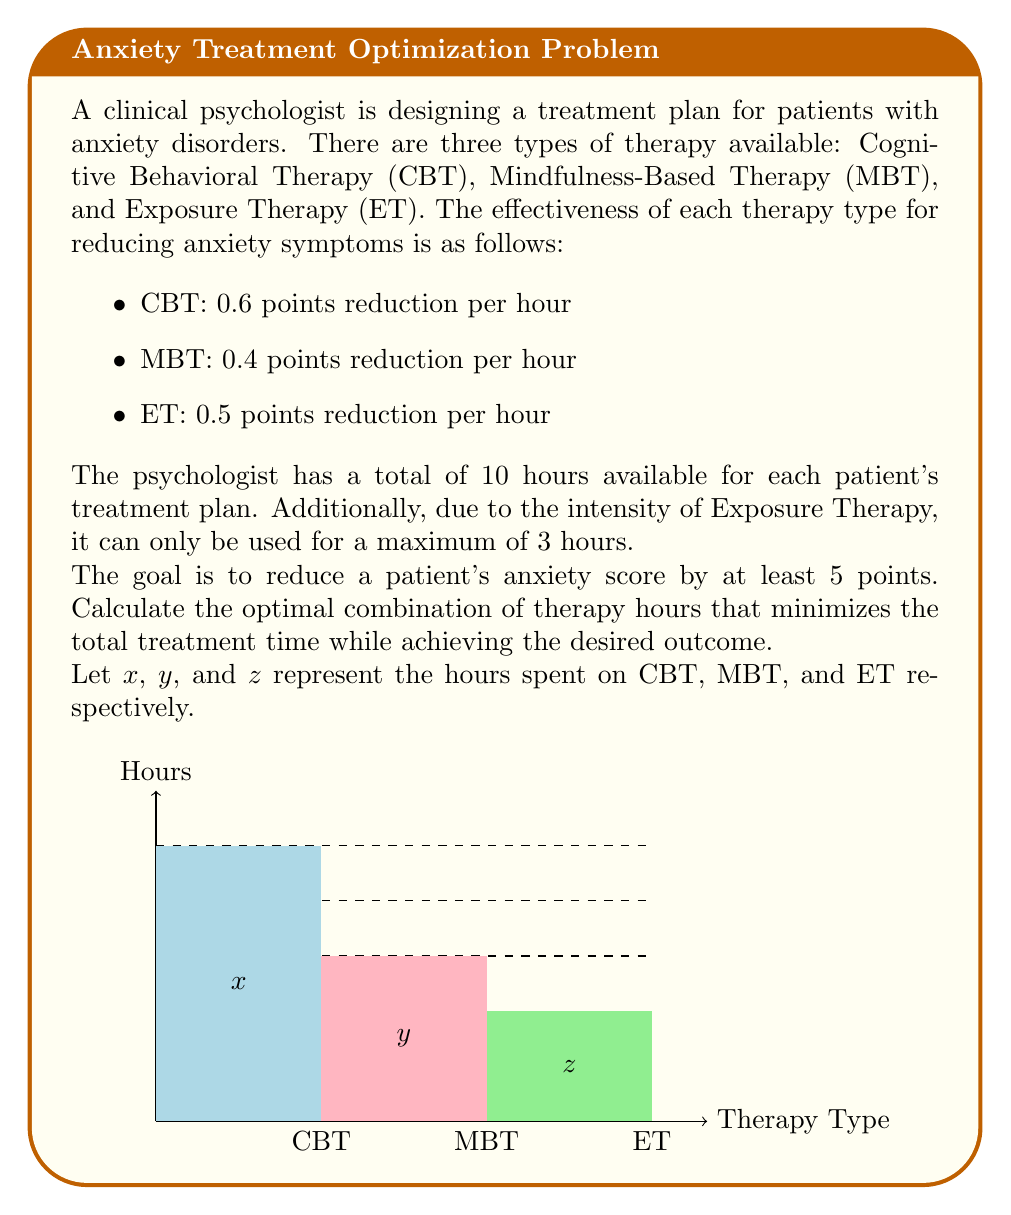Solve this math problem. To solve this optimization problem, we'll use linear programming:

1) Define the objective function:
   Minimize total time: $\min(x + y + z)$

2) Set up the constraints:
   a) Effectiveness constraint: $0.6x + 0.4y + 0.5z \geq 5$
   b) Total time constraint: $x + y + z \leq 10$
   c) Exposure Therapy constraint: $z \leq 3$
   d) Non-negativity constraints: $x \geq 0$, $y \geq 0$, $z \geq 0$

3) Solve using the simplex method or graphical method. In this case, we can use logical deduction:

   - ET is more effective than MBT, so we should use the maximum allowed ET hours: $z = 3$
   - This contributes $0.5 * 3 = 1.5$ points to anxiety reduction
   - We need $5 - 1.5 = 3.5$ more points
   - CBT is more effective than MBT, so we should use CBT for the remaining reduction
   - CBT hours needed: $3.5 / 0.6 = 5.83$ hours

4) Therefore, the optimal solution is:
   $x = 5.83$ hours of CBT
   $y = 0$ hours of MBT
   $z = 3$ hours of ET

5) Total treatment time: $5.83 + 0 + 3 = 8.83$ hours

This combination achieves the desired anxiety reduction of 5 points (0.6 * 5.83 + 0.5 * 3 = 5) in the minimum total time.
Answer: CBT: 5.83 hours, MBT: 0 hours, ET: 3 hours 